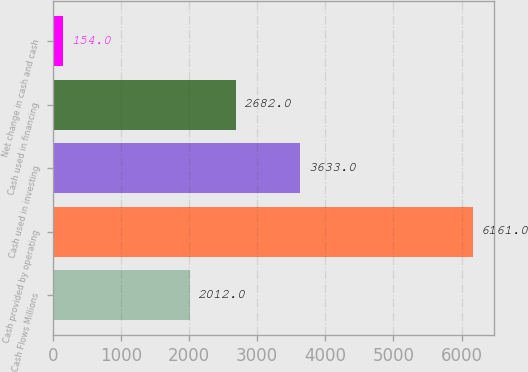Convert chart. <chart><loc_0><loc_0><loc_500><loc_500><bar_chart><fcel>Cash Flows Millions<fcel>Cash provided by operating<fcel>Cash used in investing<fcel>Cash used in financing<fcel>Net change in cash and cash<nl><fcel>2012<fcel>6161<fcel>3633<fcel>2682<fcel>154<nl></chart> 